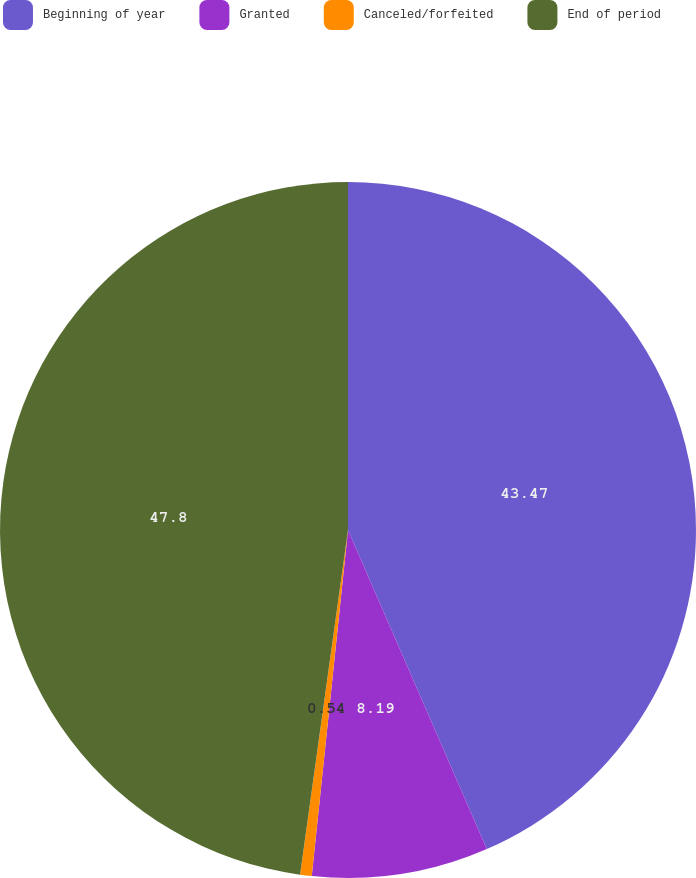Convert chart to OTSL. <chart><loc_0><loc_0><loc_500><loc_500><pie_chart><fcel>Beginning of year<fcel>Granted<fcel>Canceled/forfeited<fcel>End of period<nl><fcel>43.47%<fcel>8.19%<fcel>0.54%<fcel>47.8%<nl></chart> 